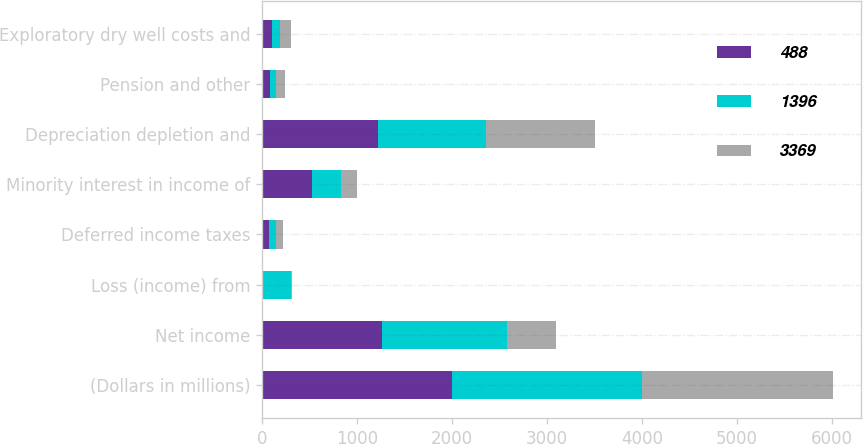Convert chart. <chart><loc_0><loc_0><loc_500><loc_500><stacked_bar_chart><ecel><fcel>(Dollars in millions)<fcel>Net income<fcel>Loss (income) from<fcel>Deferred income taxes<fcel>Minority interest in income of<fcel>Depreciation depletion and<fcel>Pension and other<fcel>Exploratory dry well costs and<nl><fcel>488<fcel>2004<fcel>1261<fcel>4<fcel>73<fcel>525<fcel>1217<fcel>82<fcel>106<nl><fcel>1396<fcel>2003<fcel>1321<fcel>305<fcel>71<fcel>302<fcel>1144<fcel>68<fcel>86<nl><fcel>3369<fcel>2002<fcel>516<fcel>4<fcel>77<fcel>173<fcel>1151<fcel>87<fcel>116<nl></chart> 